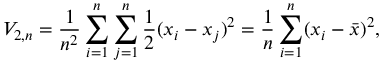Convert formula to latex. <formula><loc_0><loc_0><loc_500><loc_500>V _ { 2 , n } = { \frac { 1 } { n ^ { 2 } } } \sum _ { i = 1 } ^ { n } \sum _ { j = 1 } ^ { n } { \frac { 1 } { 2 } } ( x _ { i } - x _ { j } ) ^ { 2 } = { \frac { 1 } { n } } \sum _ { i = 1 } ^ { n } ( x _ { i } - { \bar { x } } ) ^ { 2 } ,</formula> 